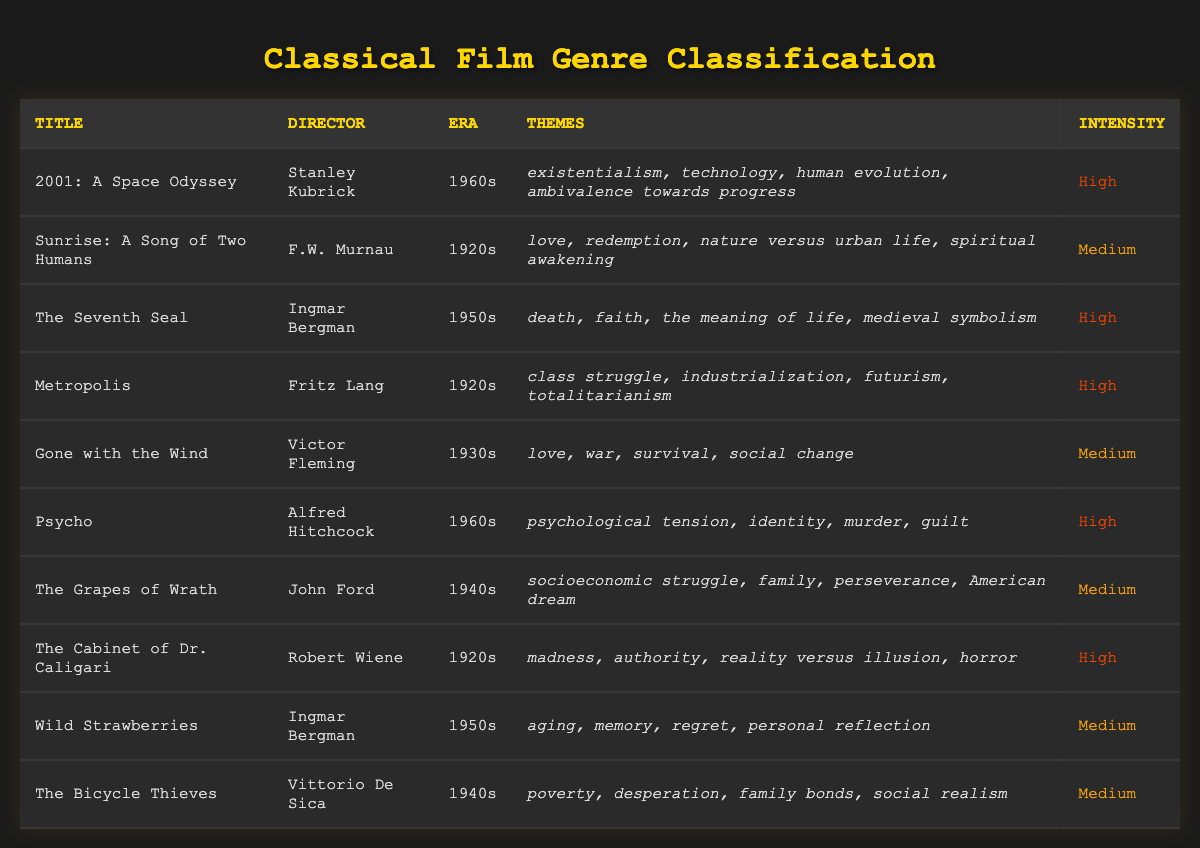What themes are present in "The Cabinet of Dr. Caligari"? The table lists the themes associated with each film. For "The Cabinet of Dr. Caligari," the themes are madness, authority, reality versus illusion, and horror.
Answer: madness, authority, reality versus illusion, horror Who directed "Sunrise: A Song of Two Humans"? Looking at the director column in the table for each film lists the directors. For "Sunrise: A Song of Two Humans," the director is F.W. Murnau.
Answer: F.W. Murnau How many films listed have a high intensity? To find the number of films classified as high intensity, we count the rows in the table where the intensity column is labeled "High." There are 5 films with high intensity.
Answer: 5 Is "Psycho" from the 1960s? We check the era column for "Psycho" in the table, which states its era is the 1960s. Therefore, the answer is yes.
Answer: Yes What is the dominant theme of the films directed by Ingmar Bergman? The table shows two films directed by Ingmar Bergman—"The Seventh Seal" and "Wild Strawberries." The themes for them are death, faith, meaning of life, and aging, memory, regret, and personal reflection. While there is no single dominant theme, "death" and "memory" are prominent.
Answer: Not defined (but "death" and "memory" are prominent) What is the average number of thematic elements in films with medium intensity? We first identify the films with medium intensity from the table: "Sunrise: A Song of Two Humans," "Gone with the Wind," "The Grapes of Wrath," "Wild Strawberries," and "The Bicycle Thieves." Each has 4, 4, 4, 4, and 4 themes respectively. Thus, the total number of themes is 4 x 5 = 20, and the average is 20 / 5 = 4.
Answer: 4 Which film has a theme related to industrialization? The theme of industrialization is present in "Metropolis." We can find this by scanning the themes of each film in the table, and "Metropolis" explicitly lists industrialization among its themes.
Answer: Metropolis Are there any films that discuss love as a theme? A quick scan of the themes column shows "Sunrise: A Song of Two Humans" and "Gone with the Wind," as both include love among their themes. Hence, the answer is yes.
Answer: Yes What is the relationship between the era of films and their intensity? To analyze the relationship, we can create a summary of how many high and medium intensity films fit into each era. The 1960s has 2 high intensity films, the 1920s has 3 high intensity films, and there are 3 medium intensity films that span across the 1930s, 1940s, and 1950s, suggesting an informal association that earlier films lean towards high intensity themes.
Answer: Earlier films lean towards high intensity themes 